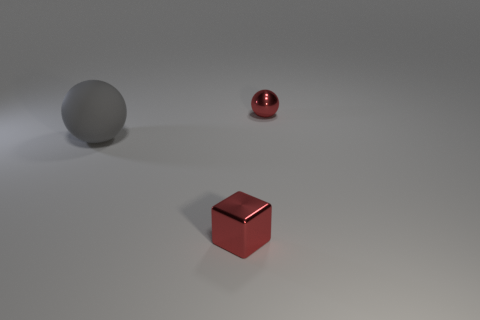What material is the ball that is the same color as the small metal cube?
Your response must be concise. Metal. Are there more small red balls that are to the left of the tiny shiny sphere than tiny blue matte balls?
Offer a terse response. No. What is the sphere that is left of the red shiny block made of?
Keep it short and to the point. Rubber. What number of tiny red things are the same material as the gray ball?
Keep it short and to the point. 0. There is a thing that is behind the small red metal cube and to the right of the gray sphere; what shape is it?
Provide a short and direct response. Sphere. How many objects are either small objects in front of the large rubber thing or small red metal objects in front of the large gray sphere?
Your answer should be compact. 1. Are there an equal number of small red spheres right of the cube and red metallic objects to the right of the red metal ball?
Your answer should be very brief. No. The shiny object behind the tiny object in front of the gray matte thing is what shape?
Your response must be concise. Sphere. Is there a red object that has the same shape as the large gray thing?
Offer a terse response. Yes. How many purple blocks are there?
Provide a succinct answer. 0. 